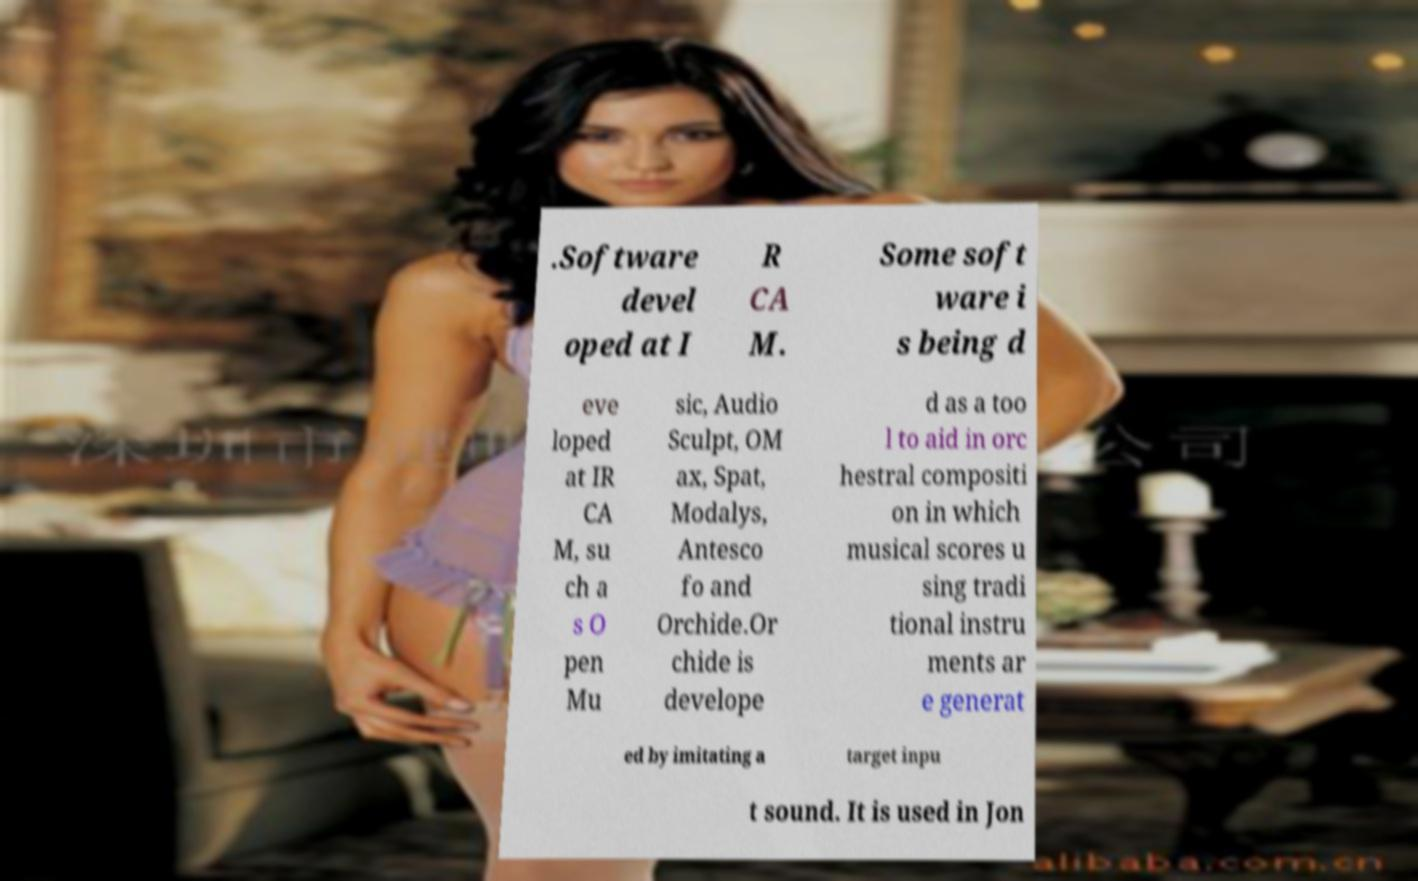Can you accurately transcribe the text from the provided image for me? .Software devel oped at I R CA M. Some soft ware i s being d eve loped at IR CA M, su ch a s O pen Mu sic, Audio Sculpt, OM ax, Spat, Modalys, Antesco fo and Orchide.Or chide is develope d as a too l to aid in orc hestral compositi on in which musical scores u sing tradi tional instru ments ar e generat ed by imitating a target inpu t sound. It is used in Jon 